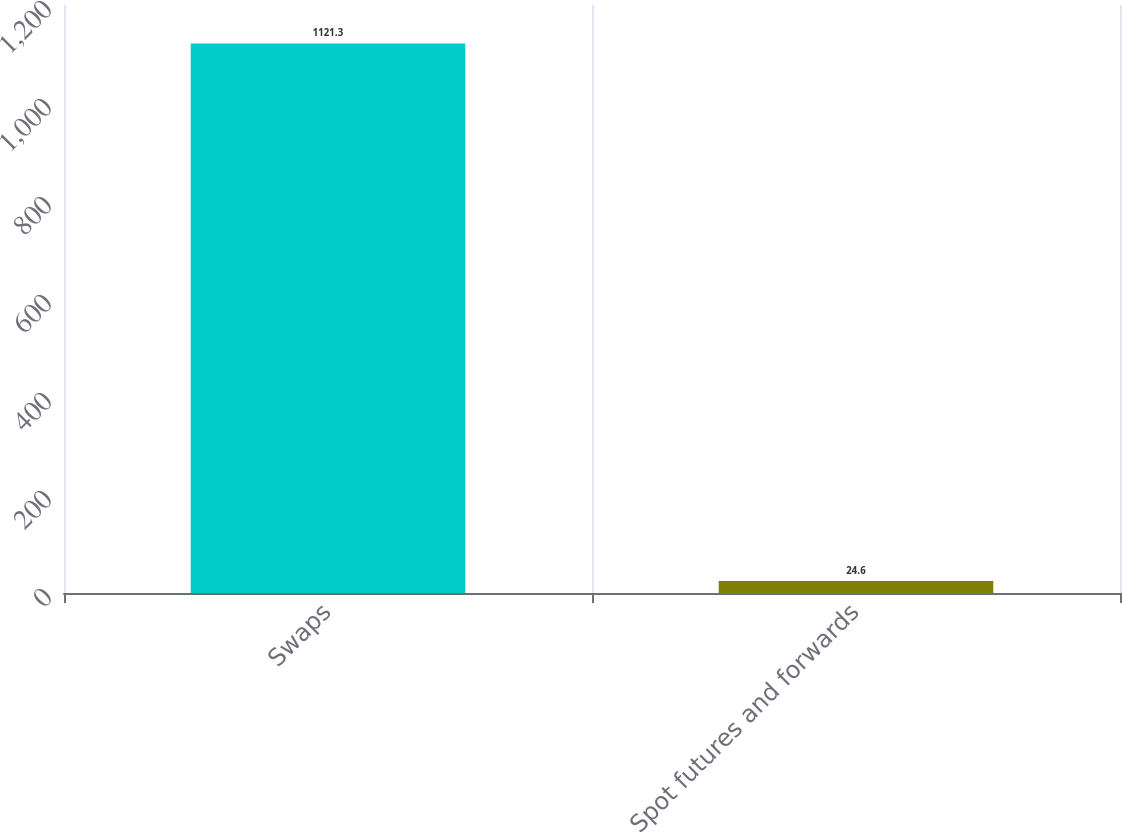Convert chart. <chart><loc_0><loc_0><loc_500><loc_500><bar_chart><fcel>Swaps<fcel>Spot futures and forwards<nl><fcel>1121.3<fcel>24.6<nl></chart> 